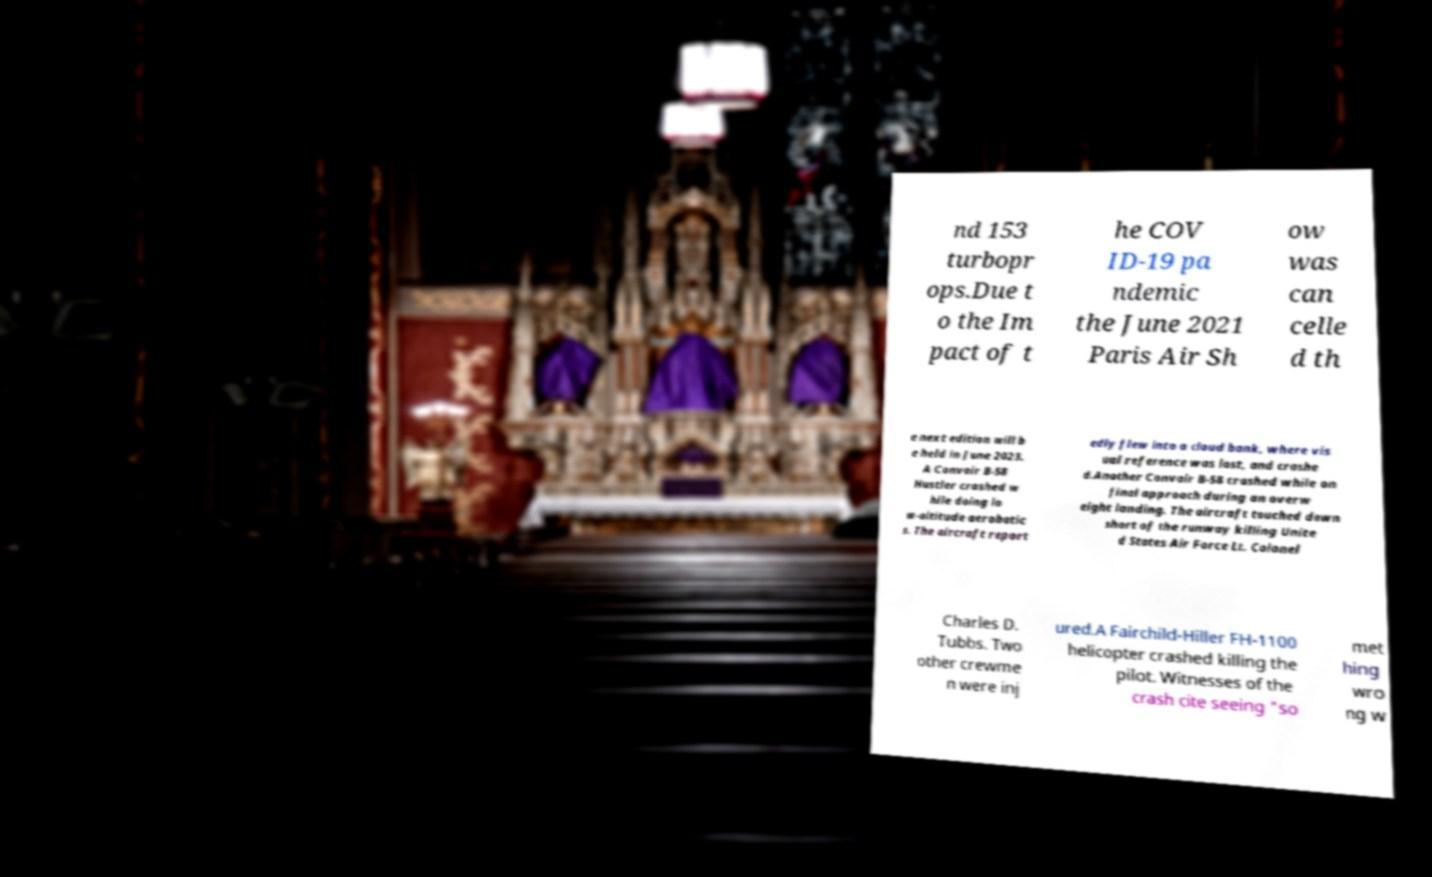Please identify and transcribe the text found in this image. nd 153 turbopr ops.Due t o the Im pact of t he COV ID-19 pa ndemic the June 2021 Paris Air Sh ow was can celle d th e next edition will b e held in June 2023. A Convair B-58 Hustler crashed w hile doing lo w-altitude aerobatic s. The aircraft report edly flew into a cloud bank, where vis ual reference was lost, and crashe d.Another Convair B-58 crashed while on final approach during an overw eight landing. The aircraft touched down short of the runway killing Unite d States Air Force Lt. Colonel Charles D. Tubbs. Two other crewme n were inj ured.A Fairchild-Hiller FH-1100 helicopter crashed killing the pilot. Witnesses of the crash cite seeing "so met hing wro ng w 